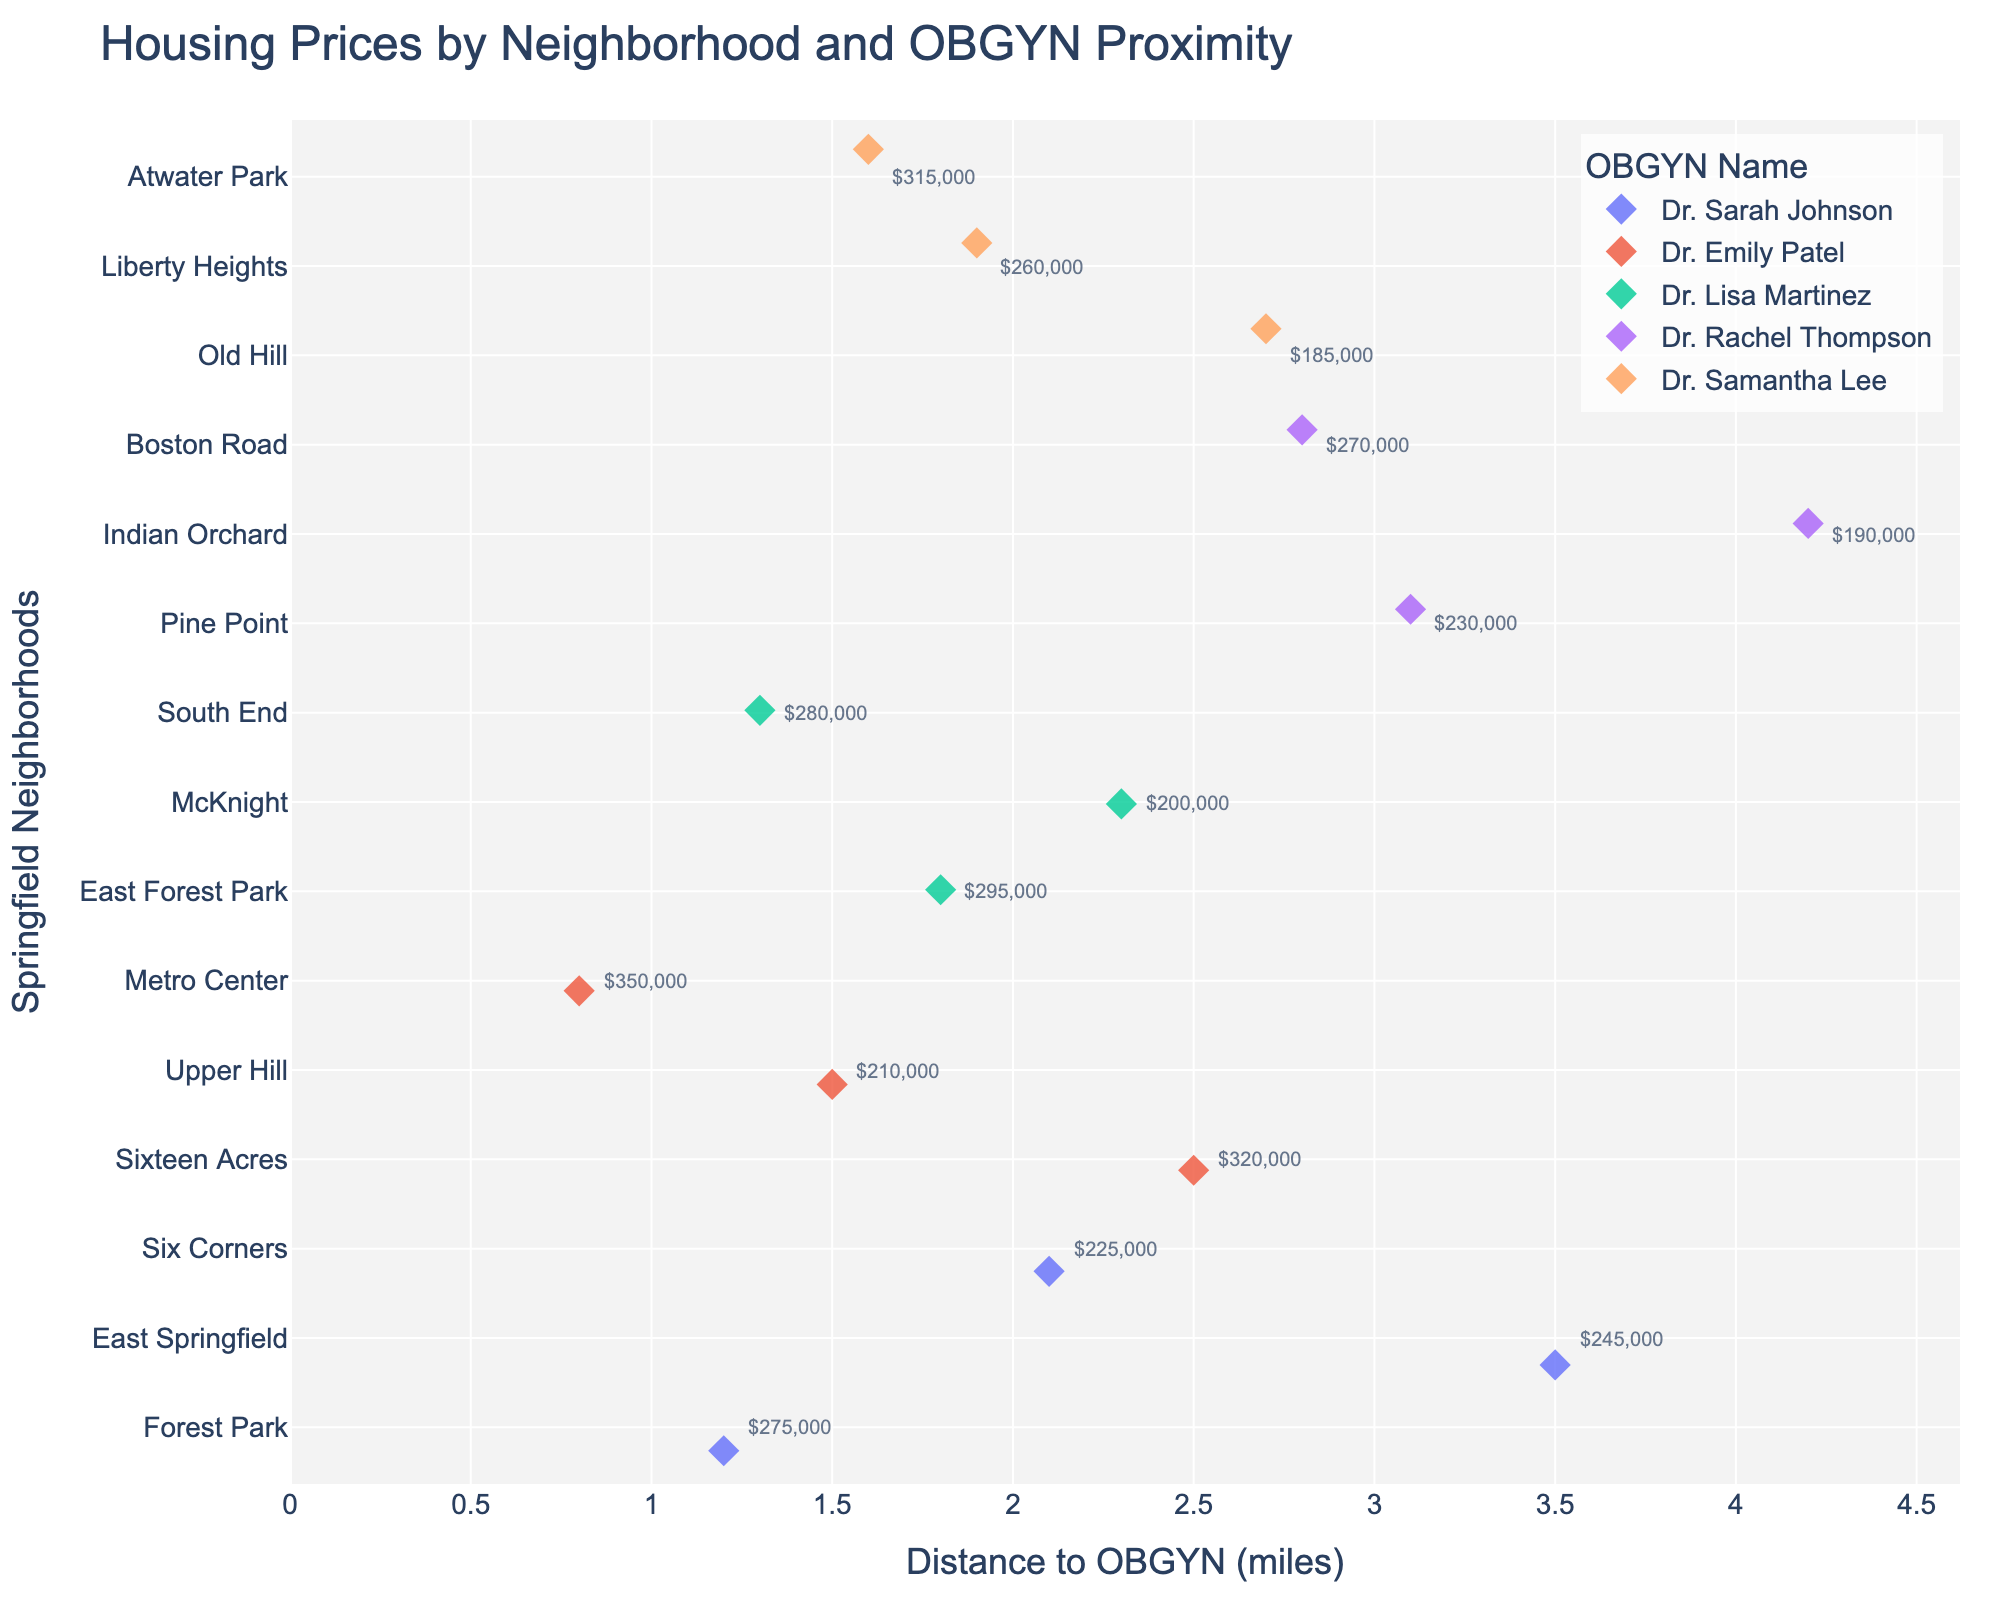Which neighborhood is closest to an OBGYN? The closest neighborhood will have the smallest distance to an OBGYN on the x-axis. Look for the smallest value of the x-axis.
Answer: Metro Center Which neighborhood has the highest house price? To find the highest house price, refer to the hover data. The neighborhood with the highest price will have a high dollar amount in the hover data.
Answer: Metro Center What is the price difference between the highest and lowest priced neighborhoods? First, find the highest price from Metro Center with $350,000. Then find the lowest price, which is Old Hill with $185,000. Subtract the lowest from the highest.
Answer: $165,000 Which OBGYN is the farthest from any neighborhood? Look for the OBGYN with the data points farthest along the x-axis. This means identifying the points farthest to the right.
Answer: Dr. Rachel Thompson How many neighborhoods have house prices above $300,000? Count the number of data points with hover data showing prices above $300,000. These neighborhoods are above that threshold.
Answer: 3 Which neighborhoods are served by Dr. Emily Patel? Look for the data points colored by Dr. Emily Patel's color. Hover over these points to see the neighborhood names.
Answer: Sixteen Acres, Upper Hill, Metro Center Which neighborhood served by Dr. Sarah Johnson has the highest price? Identify the data points for Dr. Sarah Johnson and check their hover data to find the highest price.
Answer: Forest Park What is the average distance to OBGYN for neighborhoods serviced by Dr. Lisa Martinez? Sum the distances for Dr. Lisa Martinez's neighborhoods (1.8, 2.3, 1.3) and divide by the number of neighborhoods. (1.8 + 2.3 + 1.3) / 3 = 1.8
Answer: 1.8 miles Is there a neighborhood within 2 miles of Dr. Rachel Thompson? Check the distances for Dr. Rachel Thompson's neighborhoods. All distances are greater than 2 miles. Therefore, there is no neighborhood within 2 miles.
Answer: No 